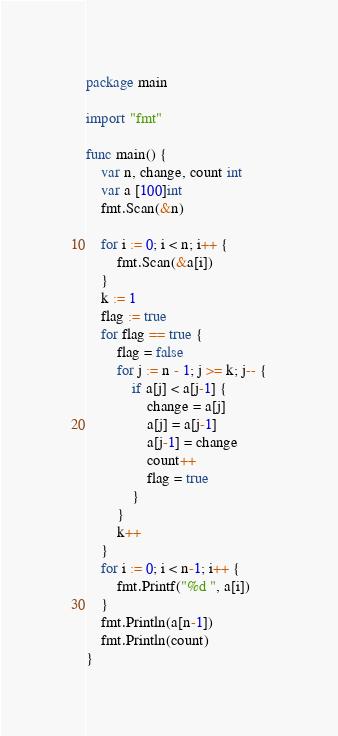Convert code to text. <code><loc_0><loc_0><loc_500><loc_500><_Go_>package main

import "fmt"

func main() {
	var n, change, count int
	var a [100]int
	fmt.Scan(&n)

	for i := 0; i < n; i++ {
		fmt.Scan(&a[i])
	}
	k := 1
	flag := true
	for flag == true {
		flag = false
		for j := n - 1; j >= k; j-- {
			if a[j] < a[j-1] {
				change = a[j]
				a[j] = a[j-1]
				a[j-1] = change
				count++
				flag = true
			}
		}
		k++
	}
	for i := 0; i < n-1; i++ {
		fmt.Printf("%d ", a[i])
	}
	fmt.Println(a[n-1])
	fmt.Println(count)
}

</code> 